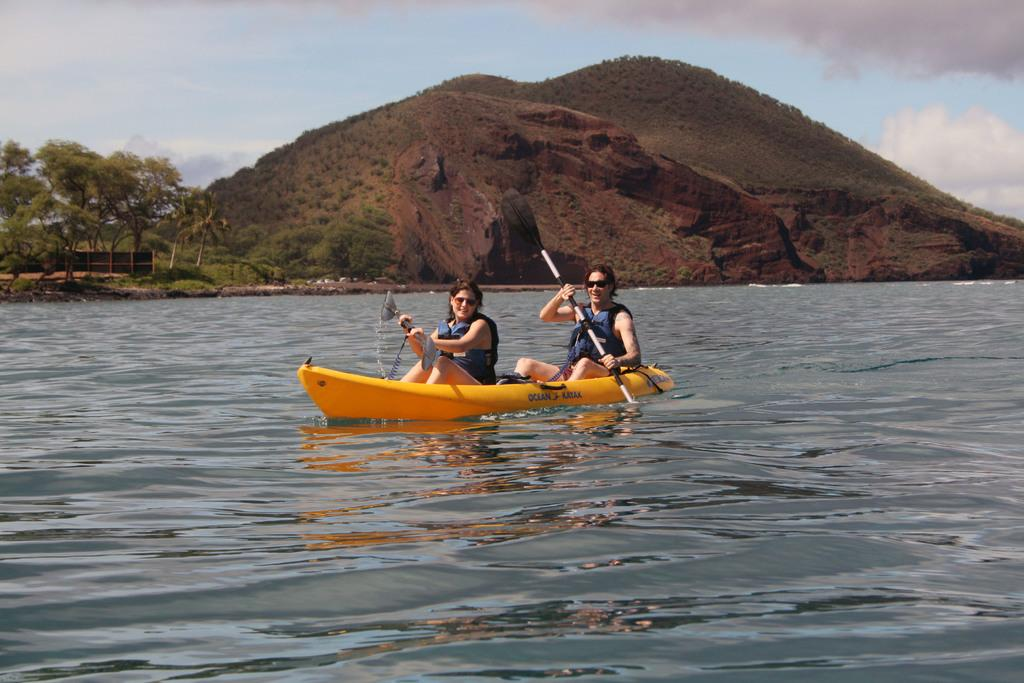How many people are in the image? There are two persons in the image. What are the persons doing in the image? The persons are sitting on a kayak and rowing with paddles. Where is the kayak located? The kayak is on water. What can be seen in the background of the image? There is a hill, trees, and the sky visible in the image. What is the condition of the sky in the image? Clouds are present in the sky. Can you tell me which toe the person on the left is using to paddle the kayak? There is no indication in the image of which toe the person is using to paddle the kayak, as the focus is on the paddles and not the person's feet. 